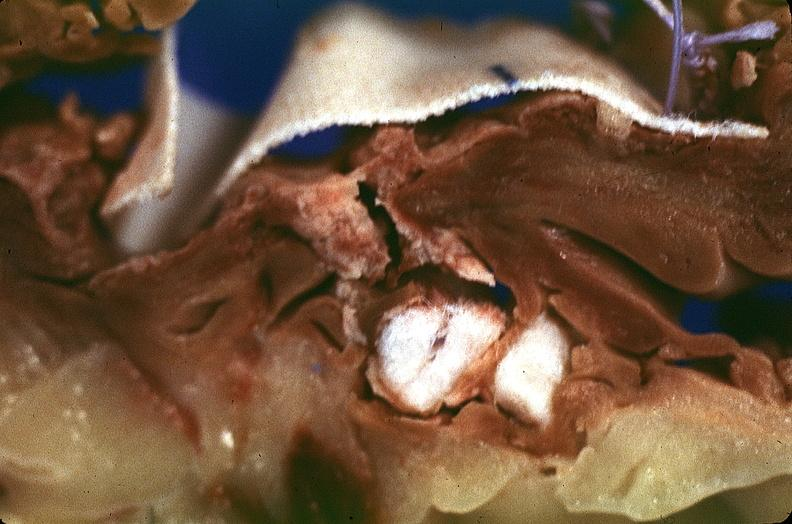s polycystic disease present?
Answer the question using a single word or phrase. No 